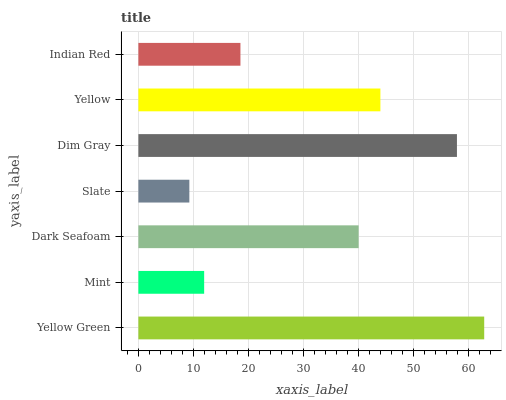Is Slate the minimum?
Answer yes or no. Yes. Is Yellow Green the maximum?
Answer yes or no. Yes. Is Mint the minimum?
Answer yes or no. No. Is Mint the maximum?
Answer yes or no. No. Is Yellow Green greater than Mint?
Answer yes or no. Yes. Is Mint less than Yellow Green?
Answer yes or no. Yes. Is Mint greater than Yellow Green?
Answer yes or no. No. Is Yellow Green less than Mint?
Answer yes or no. No. Is Dark Seafoam the high median?
Answer yes or no. Yes. Is Dark Seafoam the low median?
Answer yes or no. Yes. Is Mint the high median?
Answer yes or no. No. Is Mint the low median?
Answer yes or no. No. 